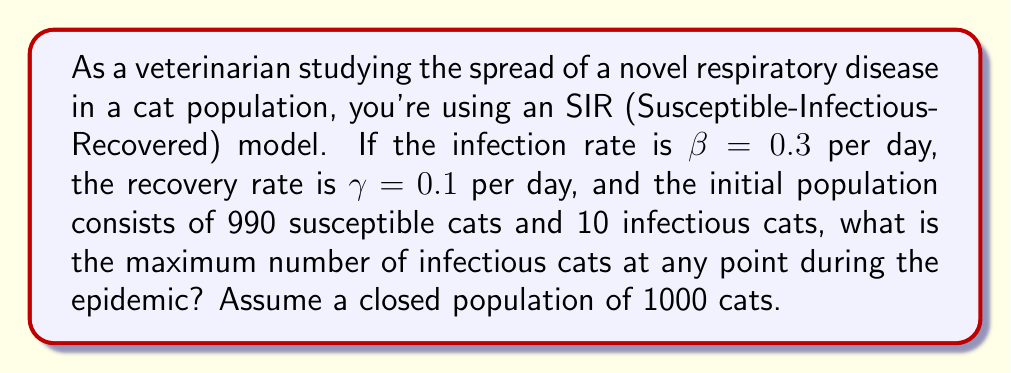Can you answer this question? To solve this problem, we'll use the SIR model equations and the concept of the basic reproduction number $R_0$. The steps are as follows:

1) The SIR model equations are:
   $$\frac{dS}{dt} = -\beta SI$$
   $$\frac{dI}{dt} = \beta SI - \gamma I$$
   $$\frac{dR}{dt} = \gamma I$$

2) The basic reproduction number $R_0$ is given by:
   $$R_0 = \frac{\beta}{\gamma} = \frac{0.3}{0.1} = 3$$

3) In an SIR model, the maximum number of infectious individuals occurs when $\frac{dI}{dt} = 0$, which happens when:
   $$S = \frac{\gamma}{\beta} = \frac{1}{R_0}$$

4) The fraction of the population that is susceptible at the peak of the epidemic is thus $\frac{1}{R_0} = \frac{1}{3}$.

5) The total population $N = S + I + R = 1000$. At the peak, $S = \frac{N}{R_0} = \frac{1000}{3} \approx 333$.

6) The number of recovered individuals at the peak can be calculated using the conservation of the total population:
   $$R = N - S - I$$

7) The maximum number of infectious individuals $I_{max}$ occurs when:
   $$I_{max} = N - S - R = N - \frac{N}{R_0} - R$$

8) We can find $R$ by using the fact that the fraction of the population that eventually gets infected in an SIR model is approximately $1 - \frac{1}{R_0} = 1 - \frac{1}{3} = \frac{2}{3}$.

9) Therefore, $R \approx \frac{2}{3}N - I_0 = \frac{2}{3} \cdot 1000 - 10 = 657$

10) Substituting this into the equation for $I_{max}$:
    $$I_{max} = 1000 - \frac{1000}{3} - 657 \approx 10$$

Thus, the maximum number of infectious cats at any point during the epidemic is approximately 10.
Answer: 10 cats 